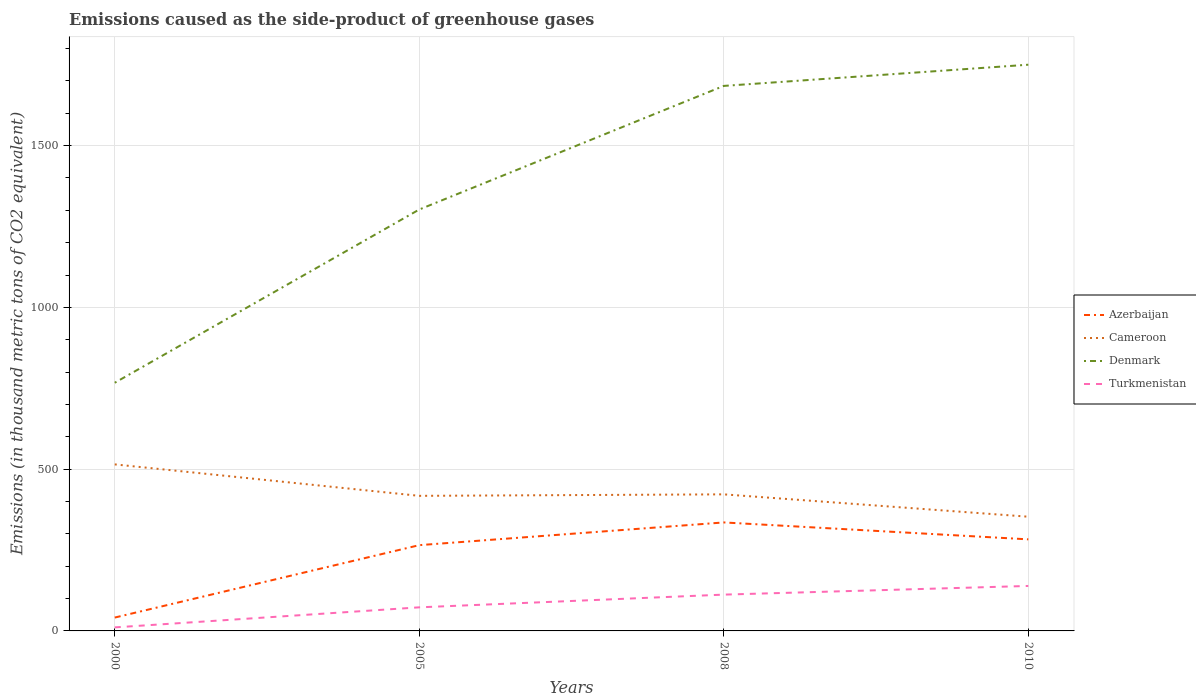How many different coloured lines are there?
Your answer should be compact. 4. Does the line corresponding to Azerbaijan intersect with the line corresponding to Denmark?
Offer a very short reply. No. Across all years, what is the maximum emissions caused as the side-product of greenhouse gases in Cameroon?
Your answer should be very brief. 353. In which year was the emissions caused as the side-product of greenhouse gases in Denmark maximum?
Your answer should be compact. 2000. What is the total emissions caused as the side-product of greenhouse gases in Turkmenistan in the graph?
Provide a short and direct response. -39.3. What is the difference between the highest and the second highest emissions caused as the side-product of greenhouse gases in Turkmenistan?
Your answer should be compact. 128.1. What is the difference between the highest and the lowest emissions caused as the side-product of greenhouse gases in Cameroon?
Keep it short and to the point. 1. Are the values on the major ticks of Y-axis written in scientific E-notation?
Your response must be concise. No. Does the graph contain any zero values?
Provide a short and direct response. No. Does the graph contain grids?
Give a very brief answer. Yes. How many legend labels are there?
Make the answer very short. 4. How are the legend labels stacked?
Your response must be concise. Vertical. What is the title of the graph?
Give a very brief answer. Emissions caused as the side-product of greenhouse gases. Does "Peru" appear as one of the legend labels in the graph?
Make the answer very short. No. What is the label or title of the X-axis?
Provide a succinct answer. Years. What is the label or title of the Y-axis?
Give a very brief answer. Emissions (in thousand metric tons of CO2 equivalent). What is the Emissions (in thousand metric tons of CO2 equivalent) of Azerbaijan in 2000?
Offer a very short reply. 41.3. What is the Emissions (in thousand metric tons of CO2 equivalent) of Cameroon in 2000?
Your response must be concise. 514.7. What is the Emissions (in thousand metric tons of CO2 equivalent) in Denmark in 2000?
Your response must be concise. 767. What is the Emissions (in thousand metric tons of CO2 equivalent) in Azerbaijan in 2005?
Offer a very short reply. 265.1. What is the Emissions (in thousand metric tons of CO2 equivalent) of Cameroon in 2005?
Your answer should be compact. 417.5. What is the Emissions (in thousand metric tons of CO2 equivalent) of Denmark in 2005?
Provide a succinct answer. 1302.5. What is the Emissions (in thousand metric tons of CO2 equivalent) in Turkmenistan in 2005?
Give a very brief answer. 72.9. What is the Emissions (in thousand metric tons of CO2 equivalent) in Azerbaijan in 2008?
Make the answer very short. 335.3. What is the Emissions (in thousand metric tons of CO2 equivalent) of Cameroon in 2008?
Keep it short and to the point. 422.1. What is the Emissions (in thousand metric tons of CO2 equivalent) in Denmark in 2008?
Your answer should be very brief. 1684.5. What is the Emissions (in thousand metric tons of CO2 equivalent) of Turkmenistan in 2008?
Give a very brief answer. 112.2. What is the Emissions (in thousand metric tons of CO2 equivalent) in Azerbaijan in 2010?
Offer a very short reply. 283. What is the Emissions (in thousand metric tons of CO2 equivalent) of Cameroon in 2010?
Offer a terse response. 353. What is the Emissions (in thousand metric tons of CO2 equivalent) of Denmark in 2010?
Give a very brief answer. 1750. What is the Emissions (in thousand metric tons of CO2 equivalent) in Turkmenistan in 2010?
Your answer should be compact. 139. Across all years, what is the maximum Emissions (in thousand metric tons of CO2 equivalent) of Azerbaijan?
Your response must be concise. 335.3. Across all years, what is the maximum Emissions (in thousand metric tons of CO2 equivalent) of Cameroon?
Your answer should be compact. 514.7. Across all years, what is the maximum Emissions (in thousand metric tons of CO2 equivalent) of Denmark?
Offer a terse response. 1750. Across all years, what is the maximum Emissions (in thousand metric tons of CO2 equivalent) in Turkmenistan?
Offer a terse response. 139. Across all years, what is the minimum Emissions (in thousand metric tons of CO2 equivalent) in Azerbaijan?
Offer a terse response. 41.3. Across all years, what is the minimum Emissions (in thousand metric tons of CO2 equivalent) in Cameroon?
Ensure brevity in your answer.  353. Across all years, what is the minimum Emissions (in thousand metric tons of CO2 equivalent) in Denmark?
Your response must be concise. 767. What is the total Emissions (in thousand metric tons of CO2 equivalent) in Azerbaijan in the graph?
Keep it short and to the point. 924.7. What is the total Emissions (in thousand metric tons of CO2 equivalent) of Cameroon in the graph?
Keep it short and to the point. 1707.3. What is the total Emissions (in thousand metric tons of CO2 equivalent) in Denmark in the graph?
Make the answer very short. 5504. What is the total Emissions (in thousand metric tons of CO2 equivalent) in Turkmenistan in the graph?
Your response must be concise. 335. What is the difference between the Emissions (in thousand metric tons of CO2 equivalent) in Azerbaijan in 2000 and that in 2005?
Give a very brief answer. -223.8. What is the difference between the Emissions (in thousand metric tons of CO2 equivalent) in Cameroon in 2000 and that in 2005?
Ensure brevity in your answer.  97.2. What is the difference between the Emissions (in thousand metric tons of CO2 equivalent) of Denmark in 2000 and that in 2005?
Give a very brief answer. -535.5. What is the difference between the Emissions (in thousand metric tons of CO2 equivalent) in Turkmenistan in 2000 and that in 2005?
Offer a very short reply. -62. What is the difference between the Emissions (in thousand metric tons of CO2 equivalent) in Azerbaijan in 2000 and that in 2008?
Ensure brevity in your answer.  -294. What is the difference between the Emissions (in thousand metric tons of CO2 equivalent) of Cameroon in 2000 and that in 2008?
Make the answer very short. 92.6. What is the difference between the Emissions (in thousand metric tons of CO2 equivalent) in Denmark in 2000 and that in 2008?
Ensure brevity in your answer.  -917.5. What is the difference between the Emissions (in thousand metric tons of CO2 equivalent) of Turkmenistan in 2000 and that in 2008?
Keep it short and to the point. -101.3. What is the difference between the Emissions (in thousand metric tons of CO2 equivalent) of Azerbaijan in 2000 and that in 2010?
Make the answer very short. -241.7. What is the difference between the Emissions (in thousand metric tons of CO2 equivalent) in Cameroon in 2000 and that in 2010?
Your response must be concise. 161.7. What is the difference between the Emissions (in thousand metric tons of CO2 equivalent) in Denmark in 2000 and that in 2010?
Give a very brief answer. -983. What is the difference between the Emissions (in thousand metric tons of CO2 equivalent) in Turkmenistan in 2000 and that in 2010?
Provide a succinct answer. -128.1. What is the difference between the Emissions (in thousand metric tons of CO2 equivalent) of Azerbaijan in 2005 and that in 2008?
Your answer should be very brief. -70.2. What is the difference between the Emissions (in thousand metric tons of CO2 equivalent) in Cameroon in 2005 and that in 2008?
Offer a very short reply. -4.6. What is the difference between the Emissions (in thousand metric tons of CO2 equivalent) in Denmark in 2005 and that in 2008?
Give a very brief answer. -382. What is the difference between the Emissions (in thousand metric tons of CO2 equivalent) of Turkmenistan in 2005 and that in 2008?
Your answer should be very brief. -39.3. What is the difference between the Emissions (in thousand metric tons of CO2 equivalent) in Azerbaijan in 2005 and that in 2010?
Ensure brevity in your answer.  -17.9. What is the difference between the Emissions (in thousand metric tons of CO2 equivalent) in Cameroon in 2005 and that in 2010?
Your answer should be very brief. 64.5. What is the difference between the Emissions (in thousand metric tons of CO2 equivalent) in Denmark in 2005 and that in 2010?
Provide a succinct answer. -447.5. What is the difference between the Emissions (in thousand metric tons of CO2 equivalent) of Turkmenistan in 2005 and that in 2010?
Your response must be concise. -66.1. What is the difference between the Emissions (in thousand metric tons of CO2 equivalent) of Azerbaijan in 2008 and that in 2010?
Make the answer very short. 52.3. What is the difference between the Emissions (in thousand metric tons of CO2 equivalent) in Cameroon in 2008 and that in 2010?
Your answer should be very brief. 69.1. What is the difference between the Emissions (in thousand metric tons of CO2 equivalent) in Denmark in 2008 and that in 2010?
Keep it short and to the point. -65.5. What is the difference between the Emissions (in thousand metric tons of CO2 equivalent) of Turkmenistan in 2008 and that in 2010?
Your answer should be very brief. -26.8. What is the difference between the Emissions (in thousand metric tons of CO2 equivalent) in Azerbaijan in 2000 and the Emissions (in thousand metric tons of CO2 equivalent) in Cameroon in 2005?
Give a very brief answer. -376.2. What is the difference between the Emissions (in thousand metric tons of CO2 equivalent) of Azerbaijan in 2000 and the Emissions (in thousand metric tons of CO2 equivalent) of Denmark in 2005?
Your answer should be compact. -1261.2. What is the difference between the Emissions (in thousand metric tons of CO2 equivalent) in Azerbaijan in 2000 and the Emissions (in thousand metric tons of CO2 equivalent) in Turkmenistan in 2005?
Keep it short and to the point. -31.6. What is the difference between the Emissions (in thousand metric tons of CO2 equivalent) in Cameroon in 2000 and the Emissions (in thousand metric tons of CO2 equivalent) in Denmark in 2005?
Ensure brevity in your answer.  -787.8. What is the difference between the Emissions (in thousand metric tons of CO2 equivalent) in Cameroon in 2000 and the Emissions (in thousand metric tons of CO2 equivalent) in Turkmenistan in 2005?
Make the answer very short. 441.8. What is the difference between the Emissions (in thousand metric tons of CO2 equivalent) of Denmark in 2000 and the Emissions (in thousand metric tons of CO2 equivalent) of Turkmenistan in 2005?
Your answer should be compact. 694.1. What is the difference between the Emissions (in thousand metric tons of CO2 equivalent) of Azerbaijan in 2000 and the Emissions (in thousand metric tons of CO2 equivalent) of Cameroon in 2008?
Ensure brevity in your answer.  -380.8. What is the difference between the Emissions (in thousand metric tons of CO2 equivalent) in Azerbaijan in 2000 and the Emissions (in thousand metric tons of CO2 equivalent) in Denmark in 2008?
Your answer should be compact. -1643.2. What is the difference between the Emissions (in thousand metric tons of CO2 equivalent) of Azerbaijan in 2000 and the Emissions (in thousand metric tons of CO2 equivalent) of Turkmenistan in 2008?
Give a very brief answer. -70.9. What is the difference between the Emissions (in thousand metric tons of CO2 equivalent) of Cameroon in 2000 and the Emissions (in thousand metric tons of CO2 equivalent) of Denmark in 2008?
Provide a succinct answer. -1169.8. What is the difference between the Emissions (in thousand metric tons of CO2 equivalent) of Cameroon in 2000 and the Emissions (in thousand metric tons of CO2 equivalent) of Turkmenistan in 2008?
Your response must be concise. 402.5. What is the difference between the Emissions (in thousand metric tons of CO2 equivalent) of Denmark in 2000 and the Emissions (in thousand metric tons of CO2 equivalent) of Turkmenistan in 2008?
Ensure brevity in your answer.  654.8. What is the difference between the Emissions (in thousand metric tons of CO2 equivalent) in Azerbaijan in 2000 and the Emissions (in thousand metric tons of CO2 equivalent) in Cameroon in 2010?
Offer a terse response. -311.7. What is the difference between the Emissions (in thousand metric tons of CO2 equivalent) in Azerbaijan in 2000 and the Emissions (in thousand metric tons of CO2 equivalent) in Denmark in 2010?
Your answer should be compact. -1708.7. What is the difference between the Emissions (in thousand metric tons of CO2 equivalent) in Azerbaijan in 2000 and the Emissions (in thousand metric tons of CO2 equivalent) in Turkmenistan in 2010?
Your response must be concise. -97.7. What is the difference between the Emissions (in thousand metric tons of CO2 equivalent) of Cameroon in 2000 and the Emissions (in thousand metric tons of CO2 equivalent) of Denmark in 2010?
Your response must be concise. -1235.3. What is the difference between the Emissions (in thousand metric tons of CO2 equivalent) of Cameroon in 2000 and the Emissions (in thousand metric tons of CO2 equivalent) of Turkmenistan in 2010?
Ensure brevity in your answer.  375.7. What is the difference between the Emissions (in thousand metric tons of CO2 equivalent) of Denmark in 2000 and the Emissions (in thousand metric tons of CO2 equivalent) of Turkmenistan in 2010?
Offer a terse response. 628. What is the difference between the Emissions (in thousand metric tons of CO2 equivalent) of Azerbaijan in 2005 and the Emissions (in thousand metric tons of CO2 equivalent) of Cameroon in 2008?
Ensure brevity in your answer.  -157. What is the difference between the Emissions (in thousand metric tons of CO2 equivalent) in Azerbaijan in 2005 and the Emissions (in thousand metric tons of CO2 equivalent) in Denmark in 2008?
Offer a terse response. -1419.4. What is the difference between the Emissions (in thousand metric tons of CO2 equivalent) of Azerbaijan in 2005 and the Emissions (in thousand metric tons of CO2 equivalent) of Turkmenistan in 2008?
Your answer should be very brief. 152.9. What is the difference between the Emissions (in thousand metric tons of CO2 equivalent) in Cameroon in 2005 and the Emissions (in thousand metric tons of CO2 equivalent) in Denmark in 2008?
Offer a terse response. -1267. What is the difference between the Emissions (in thousand metric tons of CO2 equivalent) in Cameroon in 2005 and the Emissions (in thousand metric tons of CO2 equivalent) in Turkmenistan in 2008?
Provide a short and direct response. 305.3. What is the difference between the Emissions (in thousand metric tons of CO2 equivalent) of Denmark in 2005 and the Emissions (in thousand metric tons of CO2 equivalent) of Turkmenistan in 2008?
Give a very brief answer. 1190.3. What is the difference between the Emissions (in thousand metric tons of CO2 equivalent) in Azerbaijan in 2005 and the Emissions (in thousand metric tons of CO2 equivalent) in Cameroon in 2010?
Keep it short and to the point. -87.9. What is the difference between the Emissions (in thousand metric tons of CO2 equivalent) in Azerbaijan in 2005 and the Emissions (in thousand metric tons of CO2 equivalent) in Denmark in 2010?
Ensure brevity in your answer.  -1484.9. What is the difference between the Emissions (in thousand metric tons of CO2 equivalent) of Azerbaijan in 2005 and the Emissions (in thousand metric tons of CO2 equivalent) of Turkmenistan in 2010?
Your response must be concise. 126.1. What is the difference between the Emissions (in thousand metric tons of CO2 equivalent) of Cameroon in 2005 and the Emissions (in thousand metric tons of CO2 equivalent) of Denmark in 2010?
Give a very brief answer. -1332.5. What is the difference between the Emissions (in thousand metric tons of CO2 equivalent) in Cameroon in 2005 and the Emissions (in thousand metric tons of CO2 equivalent) in Turkmenistan in 2010?
Offer a very short reply. 278.5. What is the difference between the Emissions (in thousand metric tons of CO2 equivalent) of Denmark in 2005 and the Emissions (in thousand metric tons of CO2 equivalent) of Turkmenistan in 2010?
Make the answer very short. 1163.5. What is the difference between the Emissions (in thousand metric tons of CO2 equivalent) in Azerbaijan in 2008 and the Emissions (in thousand metric tons of CO2 equivalent) in Cameroon in 2010?
Make the answer very short. -17.7. What is the difference between the Emissions (in thousand metric tons of CO2 equivalent) of Azerbaijan in 2008 and the Emissions (in thousand metric tons of CO2 equivalent) of Denmark in 2010?
Provide a succinct answer. -1414.7. What is the difference between the Emissions (in thousand metric tons of CO2 equivalent) in Azerbaijan in 2008 and the Emissions (in thousand metric tons of CO2 equivalent) in Turkmenistan in 2010?
Your answer should be compact. 196.3. What is the difference between the Emissions (in thousand metric tons of CO2 equivalent) of Cameroon in 2008 and the Emissions (in thousand metric tons of CO2 equivalent) of Denmark in 2010?
Give a very brief answer. -1327.9. What is the difference between the Emissions (in thousand metric tons of CO2 equivalent) of Cameroon in 2008 and the Emissions (in thousand metric tons of CO2 equivalent) of Turkmenistan in 2010?
Provide a succinct answer. 283.1. What is the difference between the Emissions (in thousand metric tons of CO2 equivalent) in Denmark in 2008 and the Emissions (in thousand metric tons of CO2 equivalent) in Turkmenistan in 2010?
Provide a succinct answer. 1545.5. What is the average Emissions (in thousand metric tons of CO2 equivalent) in Azerbaijan per year?
Make the answer very short. 231.18. What is the average Emissions (in thousand metric tons of CO2 equivalent) in Cameroon per year?
Offer a very short reply. 426.82. What is the average Emissions (in thousand metric tons of CO2 equivalent) of Denmark per year?
Make the answer very short. 1376. What is the average Emissions (in thousand metric tons of CO2 equivalent) in Turkmenistan per year?
Your answer should be compact. 83.75. In the year 2000, what is the difference between the Emissions (in thousand metric tons of CO2 equivalent) in Azerbaijan and Emissions (in thousand metric tons of CO2 equivalent) in Cameroon?
Your answer should be very brief. -473.4. In the year 2000, what is the difference between the Emissions (in thousand metric tons of CO2 equivalent) of Azerbaijan and Emissions (in thousand metric tons of CO2 equivalent) of Denmark?
Give a very brief answer. -725.7. In the year 2000, what is the difference between the Emissions (in thousand metric tons of CO2 equivalent) in Azerbaijan and Emissions (in thousand metric tons of CO2 equivalent) in Turkmenistan?
Your answer should be very brief. 30.4. In the year 2000, what is the difference between the Emissions (in thousand metric tons of CO2 equivalent) in Cameroon and Emissions (in thousand metric tons of CO2 equivalent) in Denmark?
Keep it short and to the point. -252.3. In the year 2000, what is the difference between the Emissions (in thousand metric tons of CO2 equivalent) of Cameroon and Emissions (in thousand metric tons of CO2 equivalent) of Turkmenistan?
Your answer should be compact. 503.8. In the year 2000, what is the difference between the Emissions (in thousand metric tons of CO2 equivalent) in Denmark and Emissions (in thousand metric tons of CO2 equivalent) in Turkmenistan?
Your answer should be compact. 756.1. In the year 2005, what is the difference between the Emissions (in thousand metric tons of CO2 equivalent) in Azerbaijan and Emissions (in thousand metric tons of CO2 equivalent) in Cameroon?
Give a very brief answer. -152.4. In the year 2005, what is the difference between the Emissions (in thousand metric tons of CO2 equivalent) of Azerbaijan and Emissions (in thousand metric tons of CO2 equivalent) of Denmark?
Make the answer very short. -1037.4. In the year 2005, what is the difference between the Emissions (in thousand metric tons of CO2 equivalent) of Azerbaijan and Emissions (in thousand metric tons of CO2 equivalent) of Turkmenistan?
Offer a terse response. 192.2. In the year 2005, what is the difference between the Emissions (in thousand metric tons of CO2 equivalent) in Cameroon and Emissions (in thousand metric tons of CO2 equivalent) in Denmark?
Your answer should be compact. -885. In the year 2005, what is the difference between the Emissions (in thousand metric tons of CO2 equivalent) of Cameroon and Emissions (in thousand metric tons of CO2 equivalent) of Turkmenistan?
Provide a short and direct response. 344.6. In the year 2005, what is the difference between the Emissions (in thousand metric tons of CO2 equivalent) of Denmark and Emissions (in thousand metric tons of CO2 equivalent) of Turkmenistan?
Offer a very short reply. 1229.6. In the year 2008, what is the difference between the Emissions (in thousand metric tons of CO2 equivalent) in Azerbaijan and Emissions (in thousand metric tons of CO2 equivalent) in Cameroon?
Your answer should be very brief. -86.8. In the year 2008, what is the difference between the Emissions (in thousand metric tons of CO2 equivalent) of Azerbaijan and Emissions (in thousand metric tons of CO2 equivalent) of Denmark?
Give a very brief answer. -1349.2. In the year 2008, what is the difference between the Emissions (in thousand metric tons of CO2 equivalent) of Azerbaijan and Emissions (in thousand metric tons of CO2 equivalent) of Turkmenistan?
Your response must be concise. 223.1. In the year 2008, what is the difference between the Emissions (in thousand metric tons of CO2 equivalent) of Cameroon and Emissions (in thousand metric tons of CO2 equivalent) of Denmark?
Provide a succinct answer. -1262.4. In the year 2008, what is the difference between the Emissions (in thousand metric tons of CO2 equivalent) of Cameroon and Emissions (in thousand metric tons of CO2 equivalent) of Turkmenistan?
Offer a terse response. 309.9. In the year 2008, what is the difference between the Emissions (in thousand metric tons of CO2 equivalent) of Denmark and Emissions (in thousand metric tons of CO2 equivalent) of Turkmenistan?
Offer a terse response. 1572.3. In the year 2010, what is the difference between the Emissions (in thousand metric tons of CO2 equivalent) in Azerbaijan and Emissions (in thousand metric tons of CO2 equivalent) in Cameroon?
Give a very brief answer. -70. In the year 2010, what is the difference between the Emissions (in thousand metric tons of CO2 equivalent) in Azerbaijan and Emissions (in thousand metric tons of CO2 equivalent) in Denmark?
Make the answer very short. -1467. In the year 2010, what is the difference between the Emissions (in thousand metric tons of CO2 equivalent) of Azerbaijan and Emissions (in thousand metric tons of CO2 equivalent) of Turkmenistan?
Keep it short and to the point. 144. In the year 2010, what is the difference between the Emissions (in thousand metric tons of CO2 equivalent) of Cameroon and Emissions (in thousand metric tons of CO2 equivalent) of Denmark?
Give a very brief answer. -1397. In the year 2010, what is the difference between the Emissions (in thousand metric tons of CO2 equivalent) of Cameroon and Emissions (in thousand metric tons of CO2 equivalent) of Turkmenistan?
Keep it short and to the point. 214. In the year 2010, what is the difference between the Emissions (in thousand metric tons of CO2 equivalent) of Denmark and Emissions (in thousand metric tons of CO2 equivalent) of Turkmenistan?
Offer a terse response. 1611. What is the ratio of the Emissions (in thousand metric tons of CO2 equivalent) in Azerbaijan in 2000 to that in 2005?
Your answer should be very brief. 0.16. What is the ratio of the Emissions (in thousand metric tons of CO2 equivalent) of Cameroon in 2000 to that in 2005?
Make the answer very short. 1.23. What is the ratio of the Emissions (in thousand metric tons of CO2 equivalent) of Denmark in 2000 to that in 2005?
Your answer should be very brief. 0.59. What is the ratio of the Emissions (in thousand metric tons of CO2 equivalent) in Turkmenistan in 2000 to that in 2005?
Give a very brief answer. 0.15. What is the ratio of the Emissions (in thousand metric tons of CO2 equivalent) of Azerbaijan in 2000 to that in 2008?
Make the answer very short. 0.12. What is the ratio of the Emissions (in thousand metric tons of CO2 equivalent) of Cameroon in 2000 to that in 2008?
Keep it short and to the point. 1.22. What is the ratio of the Emissions (in thousand metric tons of CO2 equivalent) of Denmark in 2000 to that in 2008?
Provide a short and direct response. 0.46. What is the ratio of the Emissions (in thousand metric tons of CO2 equivalent) in Turkmenistan in 2000 to that in 2008?
Ensure brevity in your answer.  0.1. What is the ratio of the Emissions (in thousand metric tons of CO2 equivalent) of Azerbaijan in 2000 to that in 2010?
Give a very brief answer. 0.15. What is the ratio of the Emissions (in thousand metric tons of CO2 equivalent) in Cameroon in 2000 to that in 2010?
Provide a succinct answer. 1.46. What is the ratio of the Emissions (in thousand metric tons of CO2 equivalent) in Denmark in 2000 to that in 2010?
Make the answer very short. 0.44. What is the ratio of the Emissions (in thousand metric tons of CO2 equivalent) in Turkmenistan in 2000 to that in 2010?
Offer a terse response. 0.08. What is the ratio of the Emissions (in thousand metric tons of CO2 equivalent) in Azerbaijan in 2005 to that in 2008?
Offer a very short reply. 0.79. What is the ratio of the Emissions (in thousand metric tons of CO2 equivalent) of Denmark in 2005 to that in 2008?
Provide a succinct answer. 0.77. What is the ratio of the Emissions (in thousand metric tons of CO2 equivalent) of Turkmenistan in 2005 to that in 2008?
Ensure brevity in your answer.  0.65. What is the ratio of the Emissions (in thousand metric tons of CO2 equivalent) of Azerbaijan in 2005 to that in 2010?
Offer a very short reply. 0.94. What is the ratio of the Emissions (in thousand metric tons of CO2 equivalent) of Cameroon in 2005 to that in 2010?
Offer a terse response. 1.18. What is the ratio of the Emissions (in thousand metric tons of CO2 equivalent) in Denmark in 2005 to that in 2010?
Your answer should be compact. 0.74. What is the ratio of the Emissions (in thousand metric tons of CO2 equivalent) of Turkmenistan in 2005 to that in 2010?
Your response must be concise. 0.52. What is the ratio of the Emissions (in thousand metric tons of CO2 equivalent) of Azerbaijan in 2008 to that in 2010?
Ensure brevity in your answer.  1.18. What is the ratio of the Emissions (in thousand metric tons of CO2 equivalent) in Cameroon in 2008 to that in 2010?
Your response must be concise. 1.2. What is the ratio of the Emissions (in thousand metric tons of CO2 equivalent) of Denmark in 2008 to that in 2010?
Offer a terse response. 0.96. What is the ratio of the Emissions (in thousand metric tons of CO2 equivalent) of Turkmenistan in 2008 to that in 2010?
Keep it short and to the point. 0.81. What is the difference between the highest and the second highest Emissions (in thousand metric tons of CO2 equivalent) in Azerbaijan?
Your answer should be compact. 52.3. What is the difference between the highest and the second highest Emissions (in thousand metric tons of CO2 equivalent) of Cameroon?
Your answer should be compact. 92.6. What is the difference between the highest and the second highest Emissions (in thousand metric tons of CO2 equivalent) of Denmark?
Provide a short and direct response. 65.5. What is the difference between the highest and the second highest Emissions (in thousand metric tons of CO2 equivalent) in Turkmenistan?
Provide a short and direct response. 26.8. What is the difference between the highest and the lowest Emissions (in thousand metric tons of CO2 equivalent) of Azerbaijan?
Your answer should be very brief. 294. What is the difference between the highest and the lowest Emissions (in thousand metric tons of CO2 equivalent) of Cameroon?
Provide a short and direct response. 161.7. What is the difference between the highest and the lowest Emissions (in thousand metric tons of CO2 equivalent) in Denmark?
Keep it short and to the point. 983. What is the difference between the highest and the lowest Emissions (in thousand metric tons of CO2 equivalent) in Turkmenistan?
Your answer should be very brief. 128.1. 